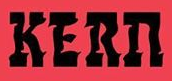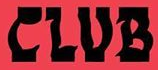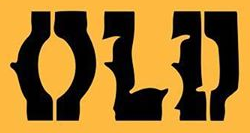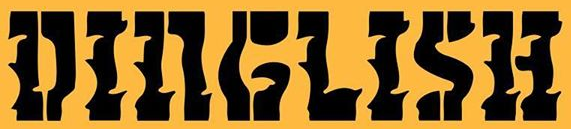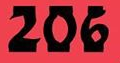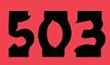What words are shown in these images in order, separated by a semicolon? KERn; CLUB; OLD; DINGLISH; 206; 503 